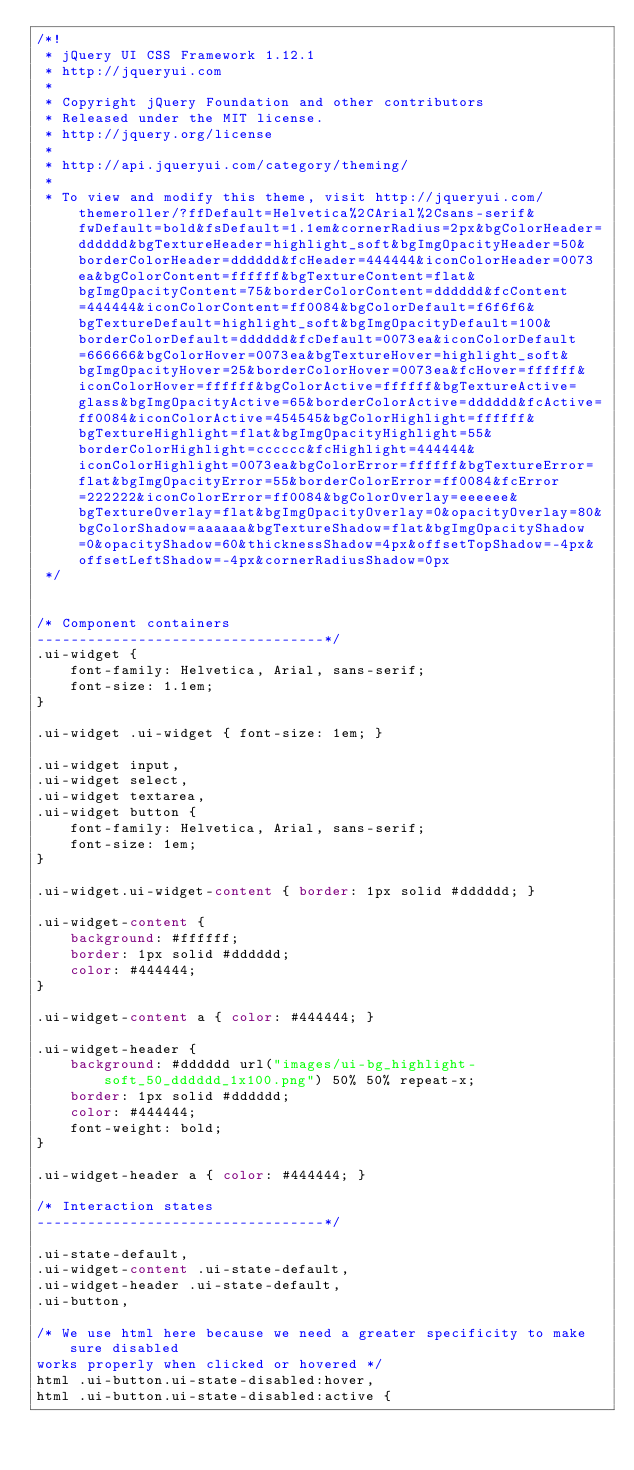<code> <loc_0><loc_0><loc_500><loc_500><_CSS_>/*!
 * jQuery UI CSS Framework 1.12.1
 * http://jqueryui.com
 *
 * Copyright jQuery Foundation and other contributors
 * Released under the MIT license.
 * http://jquery.org/license
 *
 * http://api.jqueryui.com/category/theming/
 *
 * To view and modify this theme, visit http://jqueryui.com/themeroller/?ffDefault=Helvetica%2CArial%2Csans-serif&fwDefault=bold&fsDefault=1.1em&cornerRadius=2px&bgColorHeader=dddddd&bgTextureHeader=highlight_soft&bgImgOpacityHeader=50&borderColorHeader=dddddd&fcHeader=444444&iconColorHeader=0073ea&bgColorContent=ffffff&bgTextureContent=flat&bgImgOpacityContent=75&borderColorContent=dddddd&fcContent=444444&iconColorContent=ff0084&bgColorDefault=f6f6f6&bgTextureDefault=highlight_soft&bgImgOpacityDefault=100&borderColorDefault=dddddd&fcDefault=0073ea&iconColorDefault=666666&bgColorHover=0073ea&bgTextureHover=highlight_soft&bgImgOpacityHover=25&borderColorHover=0073ea&fcHover=ffffff&iconColorHover=ffffff&bgColorActive=ffffff&bgTextureActive=glass&bgImgOpacityActive=65&borderColorActive=dddddd&fcActive=ff0084&iconColorActive=454545&bgColorHighlight=ffffff&bgTextureHighlight=flat&bgImgOpacityHighlight=55&borderColorHighlight=cccccc&fcHighlight=444444&iconColorHighlight=0073ea&bgColorError=ffffff&bgTextureError=flat&bgImgOpacityError=55&borderColorError=ff0084&fcError=222222&iconColorError=ff0084&bgColorOverlay=eeeeee&bgTextureOverlay=flat&bgImgOpacityOverlay=0&opacityOverlay=80&bgColorShadow=aaaaaa&bgTextureShadow=flat&bgImgOpacityShadow=0&opacityShadow=60&thicknessShadow=4px&offsetTopShadow=-4px&offsetLeftShadow=-4px&cornerRadiusShadow=0px
 */


/* Component containers
----------------------------------*/
.ui-widget {
    font-family: Helvetica, Arial, sans-serif;
    font-size: 1.1em;
}

.ui-widget .ui-widget { font-size: 1em; }

.ui-widget input,
.ui-widget select,
.ui-widget textarea,
.ui-widget button {
    font-family: Helvetica, Arial, sans-serif;
    font-size: 1em;
}

.ui-widget.ui-widget-content { border: 1px solid #dddddd; }

.ui-widget-content {
    background: #ffffff;
    border: 1px solid #dddddd;
    color: #444444;
}

.ui-widget-content a { color: #444444; }

.ui-widget-header {
    background: #dddddd url("images/ui-bg_highlight-soft_50_dddddd_1x100.png") 50% 50% repeat-x;
    border: 1px solid #dddddd;
    color: #444444;
    font-weight: bold;
}

.ui-widget-header a { color: #444444; }

/* Interaction states
----------------------------------*/

.ui-state-default,
.ui-widget-content .ui-state-default,
.ui-widget-header .ui-state-default,
.ui-button,

/* We use html here because we need a greater specificity to make sure disabled
works properly when clicked or hovered */
html .ui-button.ui-state-disabled:hover,
html .ui-button.ui-state-disabled:active {</code> 